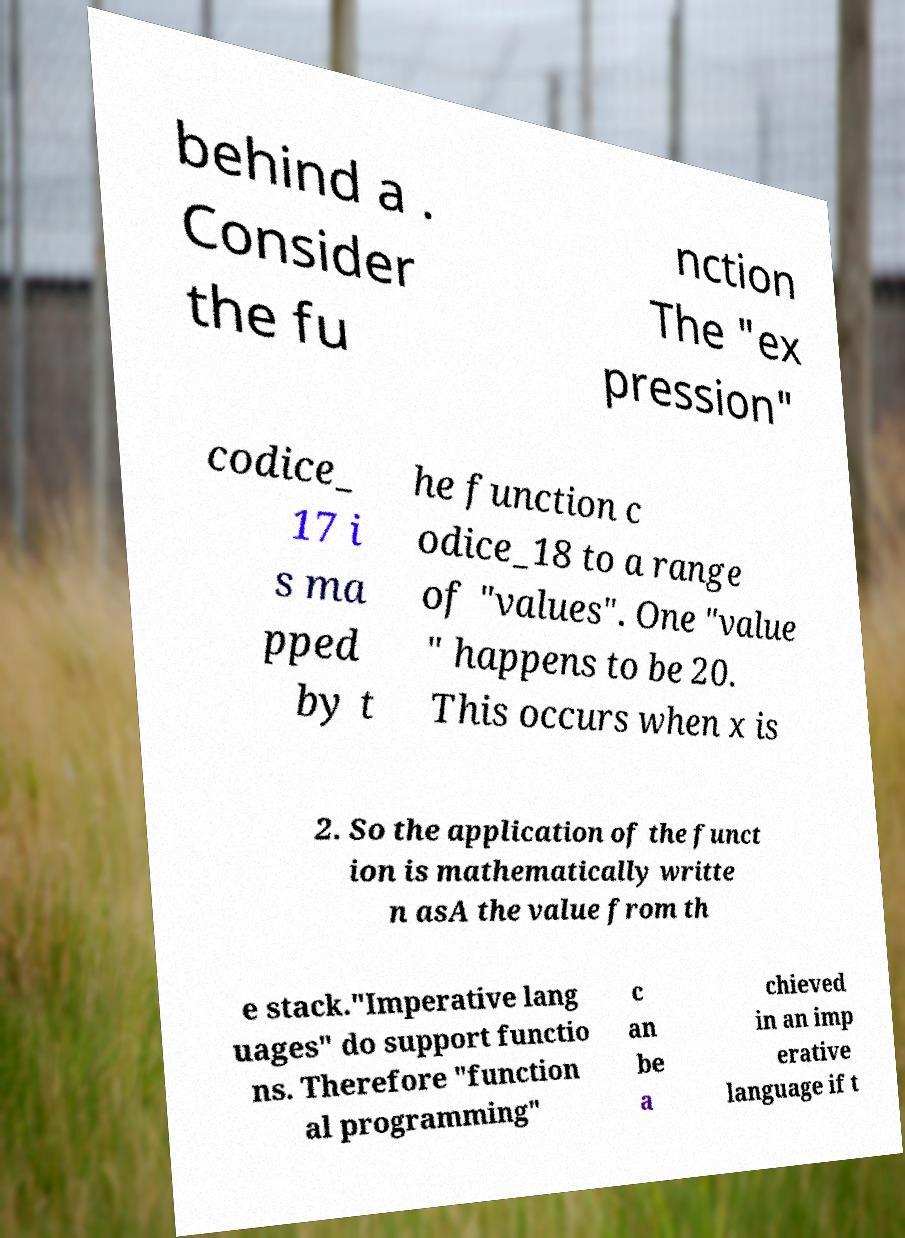For documentation purposes, I need the text within this image transcribed. Could you provide that? behind a . Consider the fu nction The "ex pression" codice_ 17 i s ma pped by t he function c odice_18 to a range of "values". One "value " happens to be 20. This occurs when x is 2. So the application of the funct ion is mathematically writte n asA the value from th e stack."Imperative lang uages" do support functio ns. Therefore "function al programming" c an be a chieved in an imp erative language if t 